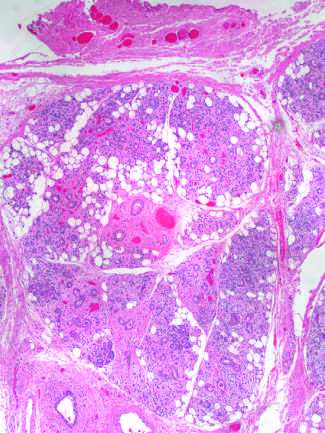what is produced by radiation therapy of the neck region?
Answer the question using a single word or phrase. Vascular changes and fibrosis of salivary glands 